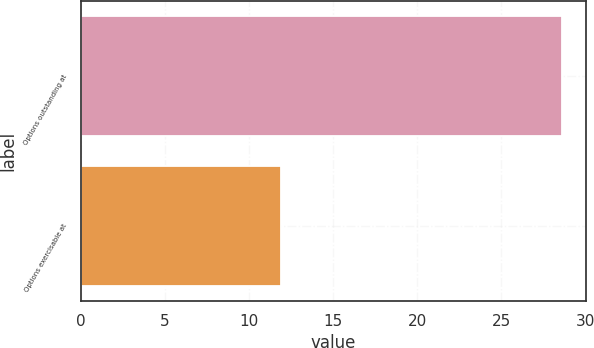Convert chart to OTSL. <chart><loc_0><loc_0><loc_500><loc_500><bar_chart><fcel>Options outstanding at<fcel>Options exercisable at<nl><fcel>28.6<fcel>11.9<nl></chart> 